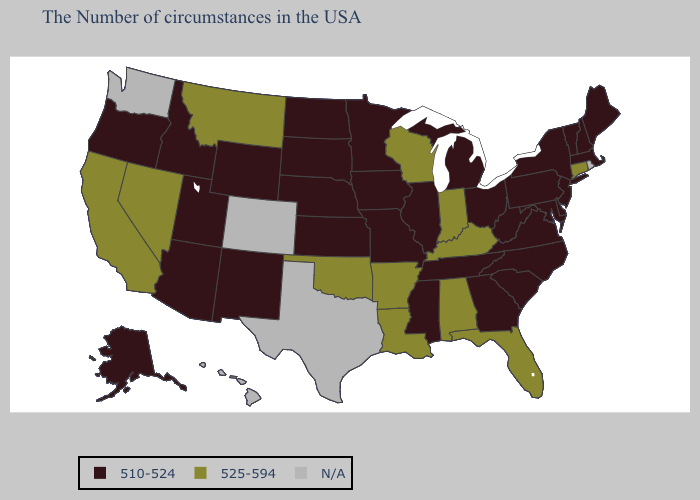Among the states that border Alabama , which have the highest value?
Keep it brief. Florida. What is the highest value in the Northeast ?
Quick response, please. 525-594. Does Connecticut have the highest value in the Northeast?
Write a very short answer. Yes. Does New Jersey have the lowest value in the Northeast?
Be succinct. Yes. What is the highest value in the USA?
Give a very brief answer. 525-594. Among the states that border Delaware , which have the lowest value?
Quick response, please. New Jersey, Maryland, Pennsylvania. What is the value of Kansas?
Keep it brief. 510-524. What is the value of Mississippi?
Write a very short answer. 510-524. What is the value of Alaska?
Be succinct. 510-524. What is the value of Texas?
Keep it brief. N/A. Does West Virginia have the lowest value in the USA?
Give a very brief answer. Yes. Is the legend a continuous bar?
Concise answer only. No. Among the states that border Vermont , which have the highest value?
Write a very short answer. Massachusetts, New Hampshire, New York. Does Massachusetts have the highest value in the USA?
Answer briefly. No. 